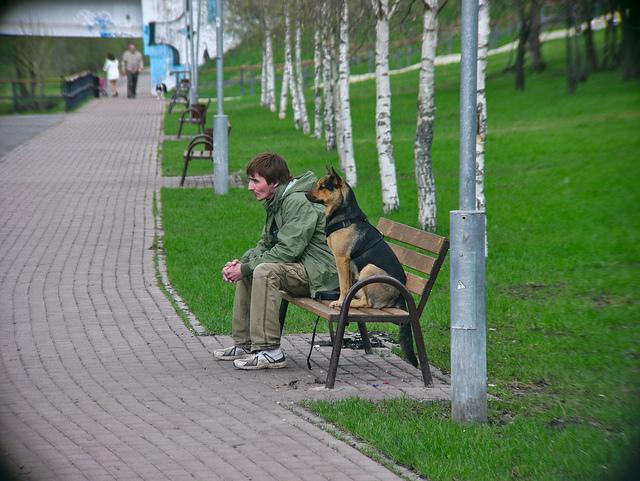What is the black strap hanging from the bench called? Please explain your reasoning. leash. The black strap is the dog's leash. 